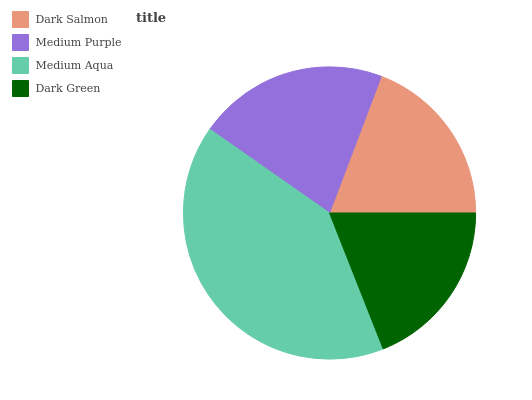Is Dark Green the minimum?
Answer yes or no. Yes. Is Medium Aqua the maximum?
Answer yes or no. Yes. Is Medium Purple the minimum?
Answer yes or no. No. Is Medium Purple the maximum?
Answer yes or no. No. Is Medium Purple greater than Dark Salmon?
Answer yes or no. Yes. Is Dark Salmon less than Medium Purple?
Answer yes or no. Yes. Is Dark Salmon greater than Medium Purple?
Answer yes or no. No. Is Medium Purple less than Dark Salmon?
Answer yes or no. No. Is Medium Purple the high median?
Answer yes or no. Yes. Is Dark Salmon the low median?
Answer yes or no. Yes. Is Dark Salmon the high median?
Answer yes or no. No. Is Dark Green the low median?
Answer yes or no. No. 